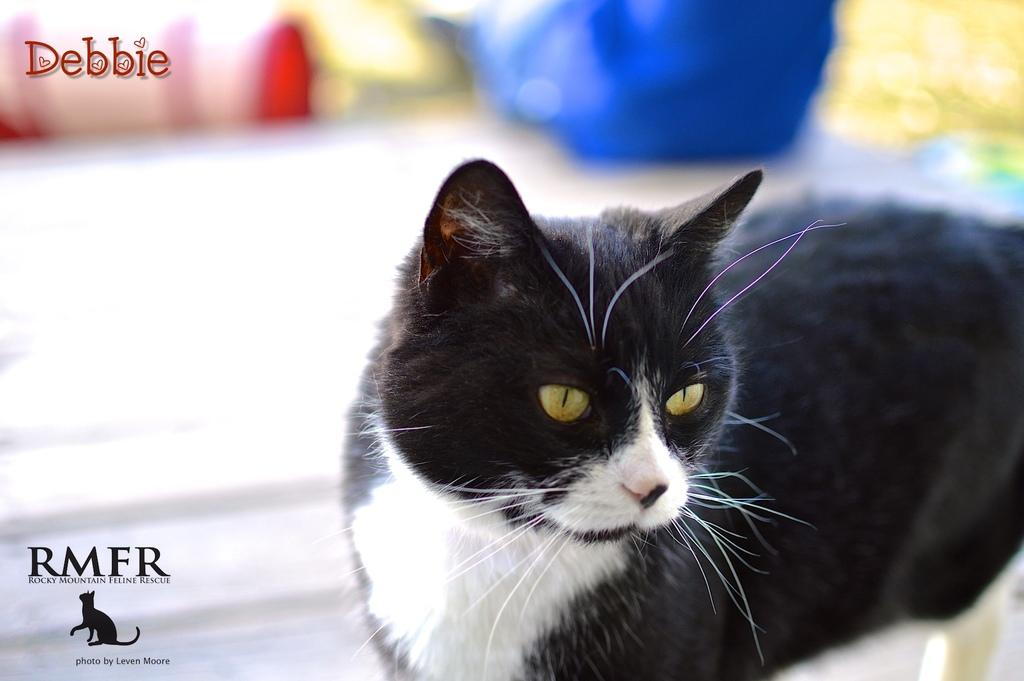What type of animal is in the image? There is a black and white cat in the image. Can you describe the background of the image? The background of the image is blurred. Are there any additional elements present in the image? Yes, there are watermarks and a logo at the top left and bottom left sides of the image. What type of coat is the toad wearing in the image? There is no toad or coat present in the image; it features a black and white cat with a blurred background and watermarks/logo. 